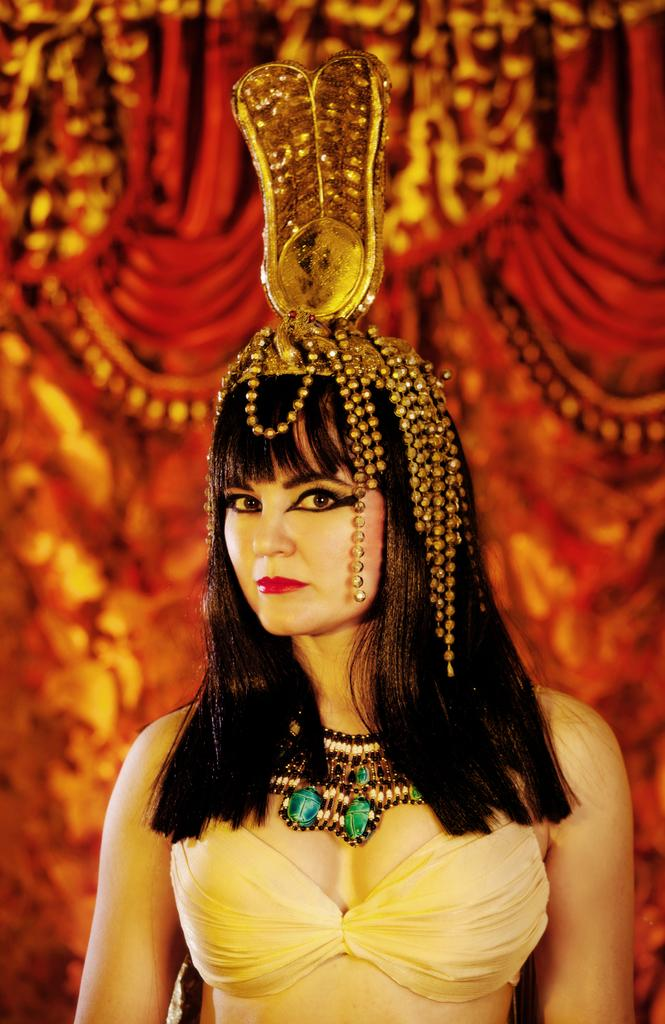Who is the main subject in the image? There is a woman in the image. What is the woman wearing in the image? The woman is wearing a necklace in the image. What can be seen on top of the woman's head? There are ornaments on top of the woman's head. Can you describe the background of the image? The background of the image is blurred. What type of quill is the woman using to write in the image? There is no quill present in the image, and the woman is not shown writing. 